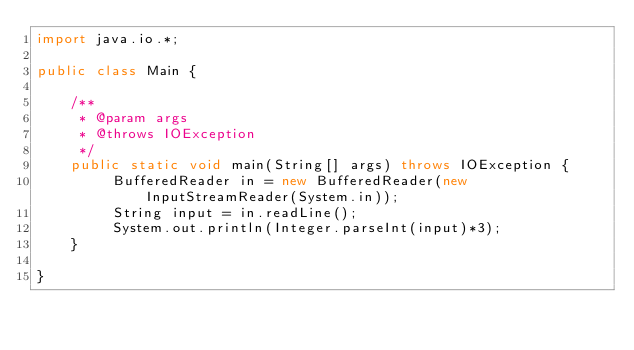Convert code to text. <code><loc_0><loc_0><loc_500><loc_500><_Java_>import java.io.*;

public class Main {

	/**
	 * @param args
	 * @throws IOException 
	 */
	public static void main(String[] args) throws IOException {
		 BufferedReader in = new BufferedReader(new InputStreamReader(System.in));
		 String input = in.readLine();
		 System.out.println(Integer.parseInt(input)*3);
	}

}</code> 